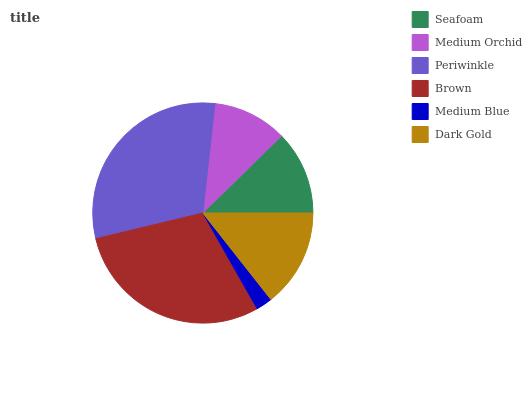Is Medium Blue the minimum?
Answer yes or no. Yes. Is Periwinkle the maximum?
Answer yes or no. Yes. Is Medium Orchid the minimum?
Answer yes or no. No. Is Medium Orchid the maximum?
Answer yes or no. No. Is Seafoam greater than Medium Orchid?
Answer yes or no. Yes. Is Medium Orchid less than Seafoam?
Answer yes or no. Yes. Is Medium Orchid greater than Seafoam?
Answer yes or no. No. Is Seafoam less than Medium Orchid?
Answer yes or no. No. Is Dark Gold the high median?
Answer yes or no. Yes. Is Seafoam the low median?
Answer yes or no. Yes. Is Seafoam the high median?
Answer yes or no. No. Is Medium Blue the low median?
Answer yes or no. No. 